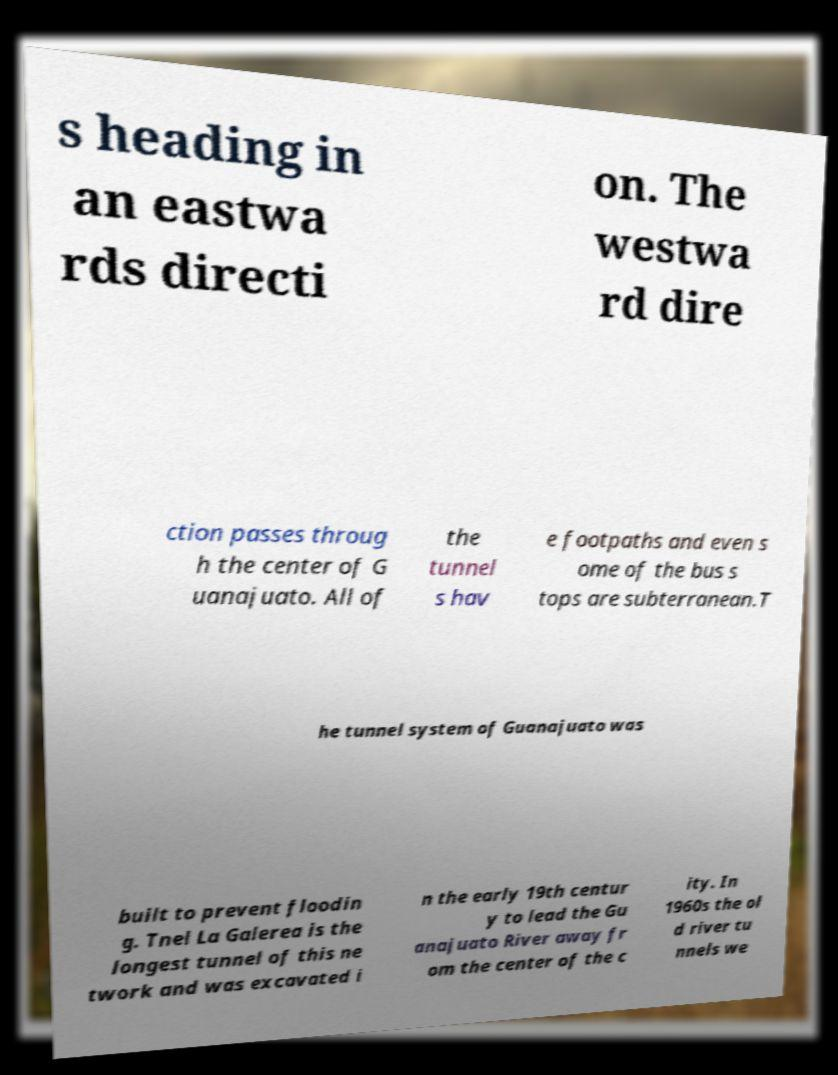What messages or text are displayed in this image? I need them in a readable, typed format. s heading in an eastwa rds directi on. The westwa rd dire ction passes throug h the center of G uanajuato. All of the tunnel s hav e footpaths and even s ome of the bus s tops are subterranean.T he tunnel system of Guanajuato was built to prevent floodin g. Tnel La Galerea is the longest tunnel of this ne twork and was excavated i n the early 19th centur y to lead the Gu anajuato River away fr om the center of the c ity. In 1960s the ol d river tu nnels we 